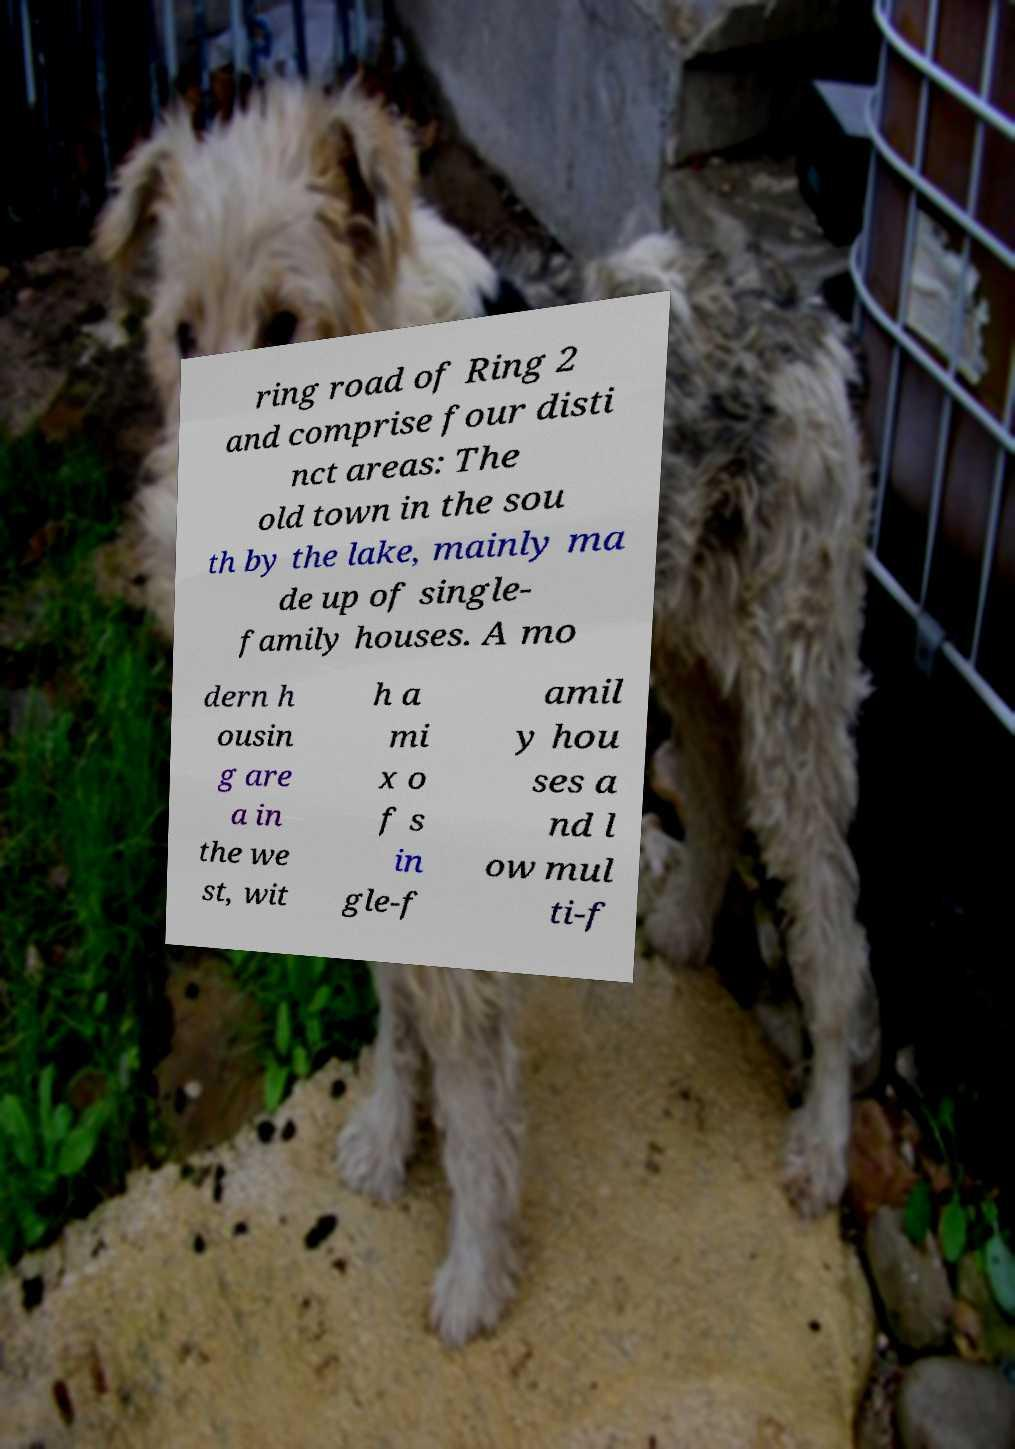There's text embedded in this image that I need extracted. Can you transcribe it verbatim? ring road of Ring 2 and comprise four disti nct areas: The old town in the sou th by the lake, mainly ma de up of single- family houses. A mo dern h ousin g are a in the we st, wit h a mi x o f s in gle-f amil y hou ses a nd l ow mul ti-f 